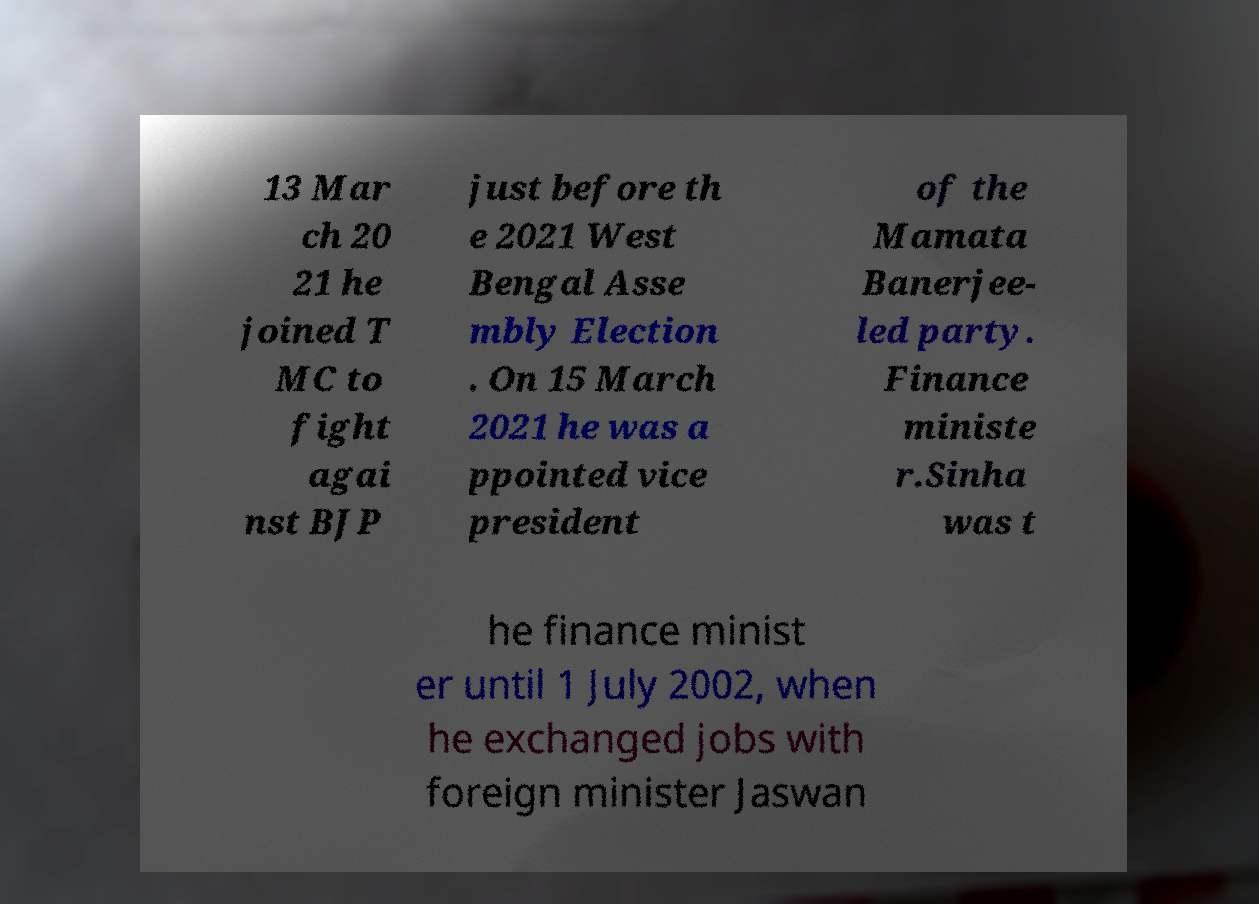Can you read and provide the text displayed in the image?This photo seems to have some interesting text. Can you extract and type it out for me? 13 Mar ch 20 21 he joined T MC to fight agai nst BJP just before th e 2021 West Bengal Asse mbly Election . On 15 March 2021 he was a ppointed vice president of the Mamata Banerjee- led party. Finance ministe r.Sinha was t he finance minist er until 1 July 2002, when he exchanged jobs with foreign minister Jaswan 